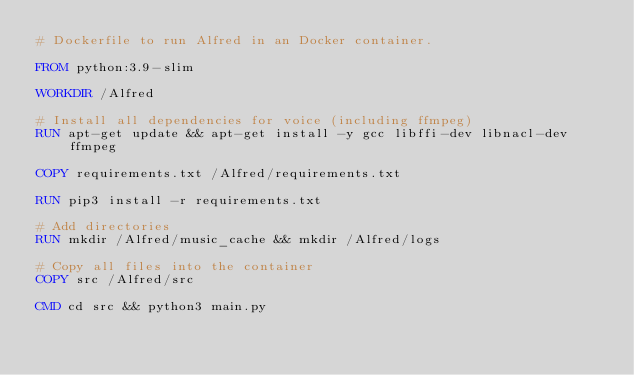<code> <loc_0><loc_0><loc_500><loc_500><_Dockerfile_># Dockerfile to run Alfred in an Docker container.

FROM python:3.9-slim

WORKDIR /Alfred

# Install all dependencies for voice (including ffmpeg)
RUN apt-get update && apt-get install -y gcc libffi-dev libnacl-dev ffmpeg

COPY requirements.txt /Alfred/requirements.txt

RUN pip3 install -r requirements.txt

# Add directories
RUN mkdir /Alfred/music_cache && mkdir /Alfred/logs

# Copy all files into the container
COPY src /Alfred/src

CMD cd src && python3 main.py
</code> 